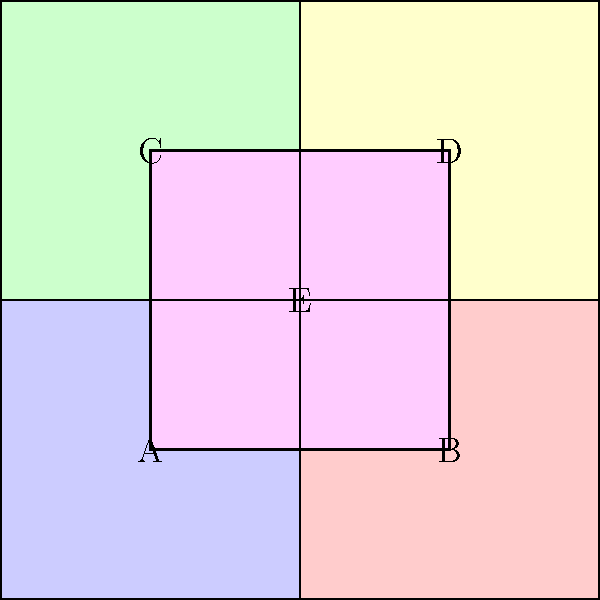In the given electoral district map, which district exhibits the characteristics of gerrymandering, potentially violating the principle of compactness in district design? To determine which district exhibits characteristics of gerrymandering, we need to analyze each district's shape and compactness:

1. Districts A, B, C, and D are perfect squares, which are considered highly compact and ideal shapes for electoral districts.

2. District E, however, has an unusual shape that cuts through the center of the map and touches all four corners of the larger square.

3. The principle of compactness in district design suggests that districts should be as compact as possible, often resembling simple geometric shapes like circles or squares.

4. Gerrymandering often results in bizarrely shaped districts that are designed to include or exclude certain populations for political advantage.

5. District E's shape is not compact and could potentially be used to connect disparate areas of the map, which is a common tactic in gerrymandering.

6. The unusual shape of District E could allow it to potentially split communities of interest or combine unrelated communities, which are other indicators of gerrymandering.

Given these factors, District E shows the most characteristics associated with gerrymandering and potential violation of the compactness principle.
Answer: District E 